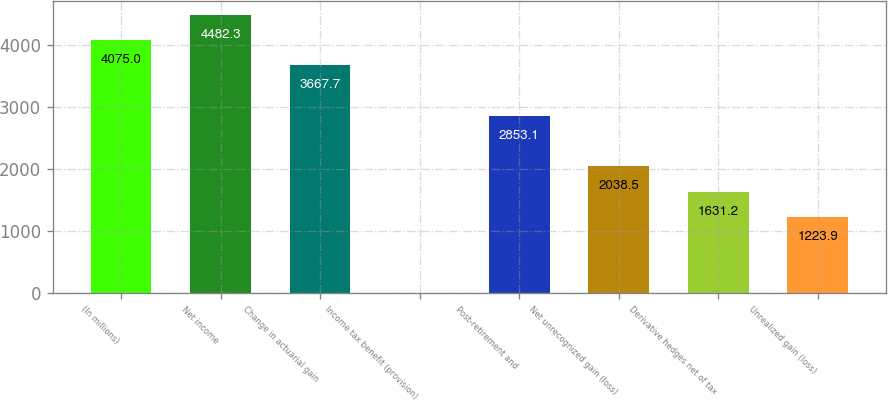Convert chart to OTSL. <chart><loc_0><loc_0><loc_500><loc_500><bar_chart><fcel>(In millions)<fcel>Net income<fcel>Change in actuarial gain<fcel>Income tax benefit (provision)<fcel>Post-retirement and<fcel>Net unrecognized gain (loss)<fcel>Derivative hedges net of tax<fcel>Unrealized gain (loss)<nl><fcel>4075<fcel>4482.3<fcel>3667.7<fcel>2<fcel>2853.1<fcel>2038.5<fcel>1631.2<fcel>1223.9<nl></chart> 